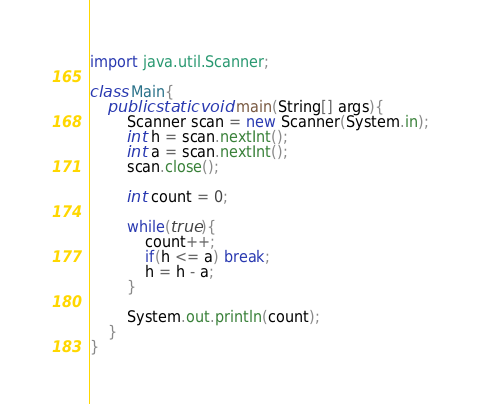<code> <loc_0><loc_0><loc_500><loc_500><_Java_>import java.util.Scanner;

class Main{
    public static void main(String[] args){
        Scanner scan = new Scanner(System.in);
        int h = scan.nextInt();
        int a = scan.nextInt();
        scan.close();

        int count = 0;

        while(true){
            count++;
            if(h <= a) break;
            h = h - a;
        }

        System.out.println(count);
    }
}</code> 